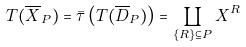<formula> <loc_0><loc_0><loc_500><loc_500>T ( \overline { X } _ { P } ) = \bar { \tau } \left ( T ( \overline { D } _ { P } ) \right ) = \coprod _ { \{ R \} \subseteq P } X ^ { R }</formula> 